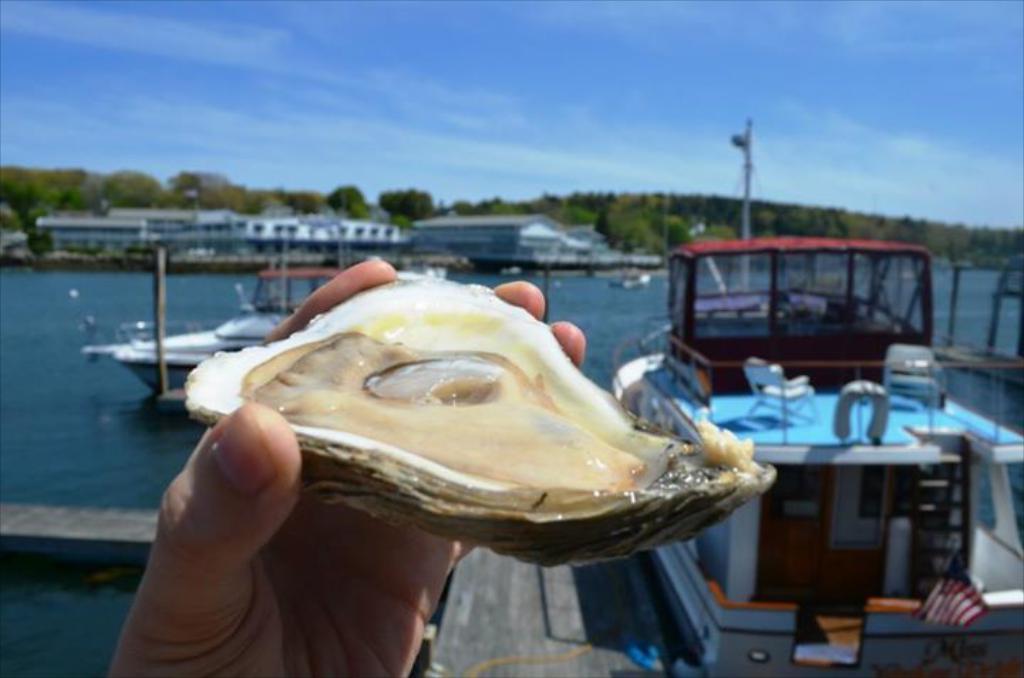Please provide a concise description of this image. Here in this picture we can see a person holding an oyster in hand and in front of that we can see boats present in the river, as we can see water present all over there and in the far we can see buildings and sheds present over there and we can also see trees and plants present all over there and we can see clouds in the sky over there. 